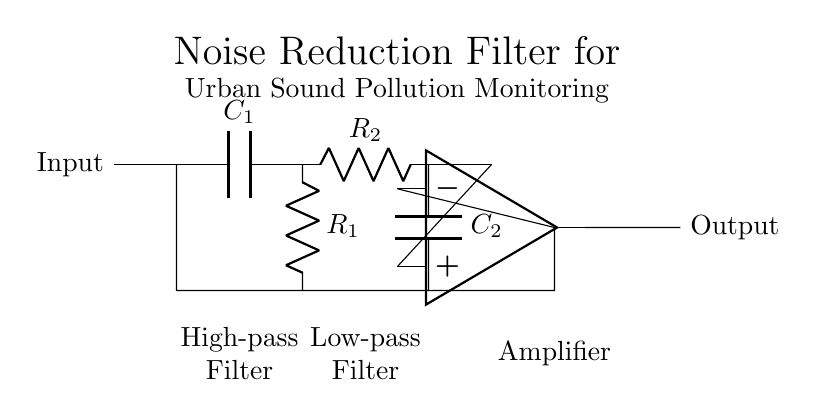What are the components used in the filter? The filter comprises two capacitors, two resistors, and an operational amplifier. These components are essential for creating the high-pass and low-pass functionalities necessary for noise reduction.
Answer: Two capacitors, two resistors, one operational amplifier What is the function of the operational amplifier in this circuit? The operational amplifier amplifies the output signal after the filtering process, ensuring that the desired audio signals stand out while noise is effectively reduced. Its position after the filters indicates its role in signal conditioning.
Answer: Amplification Which filter type is placed first in the circuit? The circuit shows a high-pass filter as the first stage, indicated by the placement of the capacitor and resistor before the low-pass filter in the signal pathway. This allows high-frequency sounds to pass while blocking lower frequencies.
Answer: High-pass filter How does the circuit reduce noise pollution? The combination of the high-pass and low-pass filters allows the circuit to remove unwanted frequencies (both low and high), effectively isolating the sounds that are meaningful for urban monitoring while minimizing background noise.
Answer: By filtering frequencies What is the labeling of the resistors in the circuit? The resistors are labeled as R1 and R2, with R1 being part of the high-pass filter and R2 as part of the low-pass filter, both crucial for defining the frequency behavior of their respective filters.
Answer: R1 and R2 